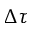Convert formula to latex. <formula><loc_0><loc_0><loc_500><loc_500>\Delta \tau</formula> 